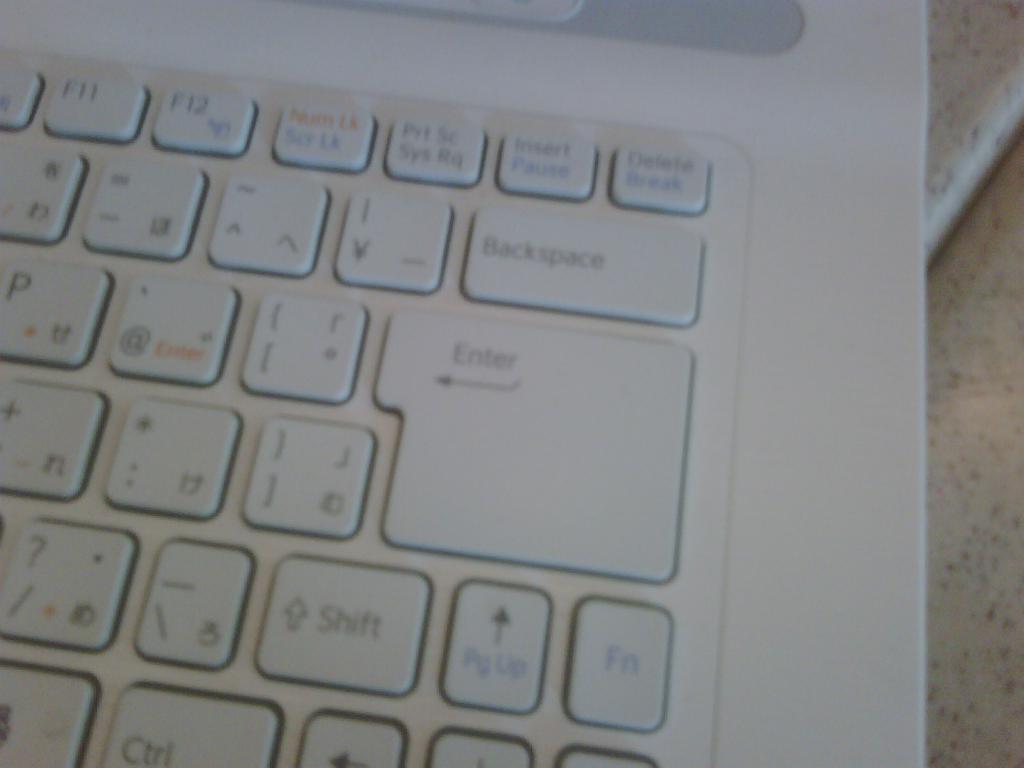What is the big button?
Provide a succinct answer. Enter. What is the key above the enter key?
Your answer should be very brief. Backspace. 